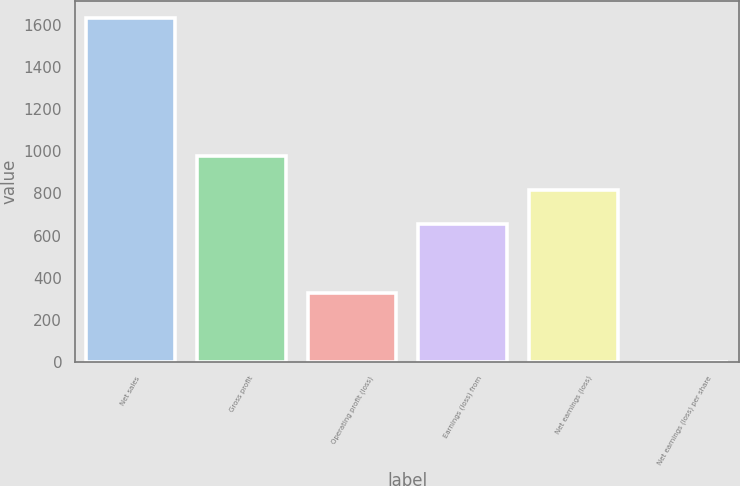Convert chart to OTSL. <chart><loc_0><loc_0><loc_500><loc_500><bar_chart><fcel>Net sales<fcel>Gross profit<fcel>Operating profit (loss)<fcel>Earnings (loss) from<fcel>Net earnings (loss)<fcel>Net earnings (loss) per share<nl><fcel>1633<fcel>980.26<fcel>327.52<fcel>653.88<fcel>817.07<fcel>1.15<nl></chart> 